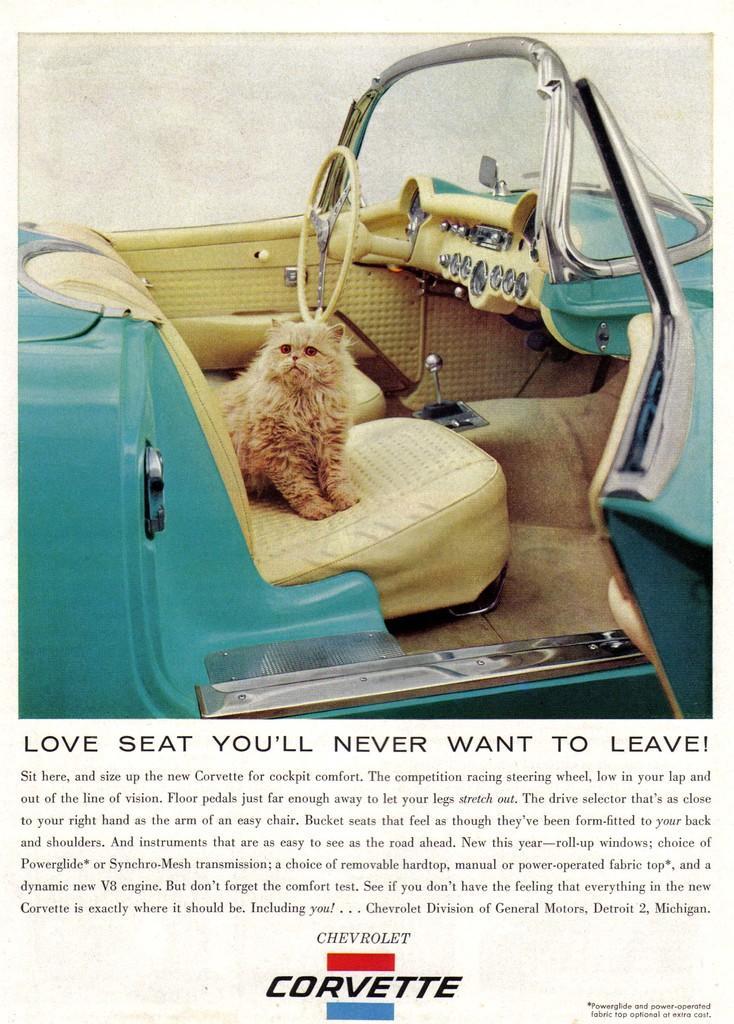In one or two sentences, can you explain what this image depicts? In this picture this is a photo and some matter is written according to the photo and it contains several borders in that picture there is a car in that car one dog is sitting on the seat. 